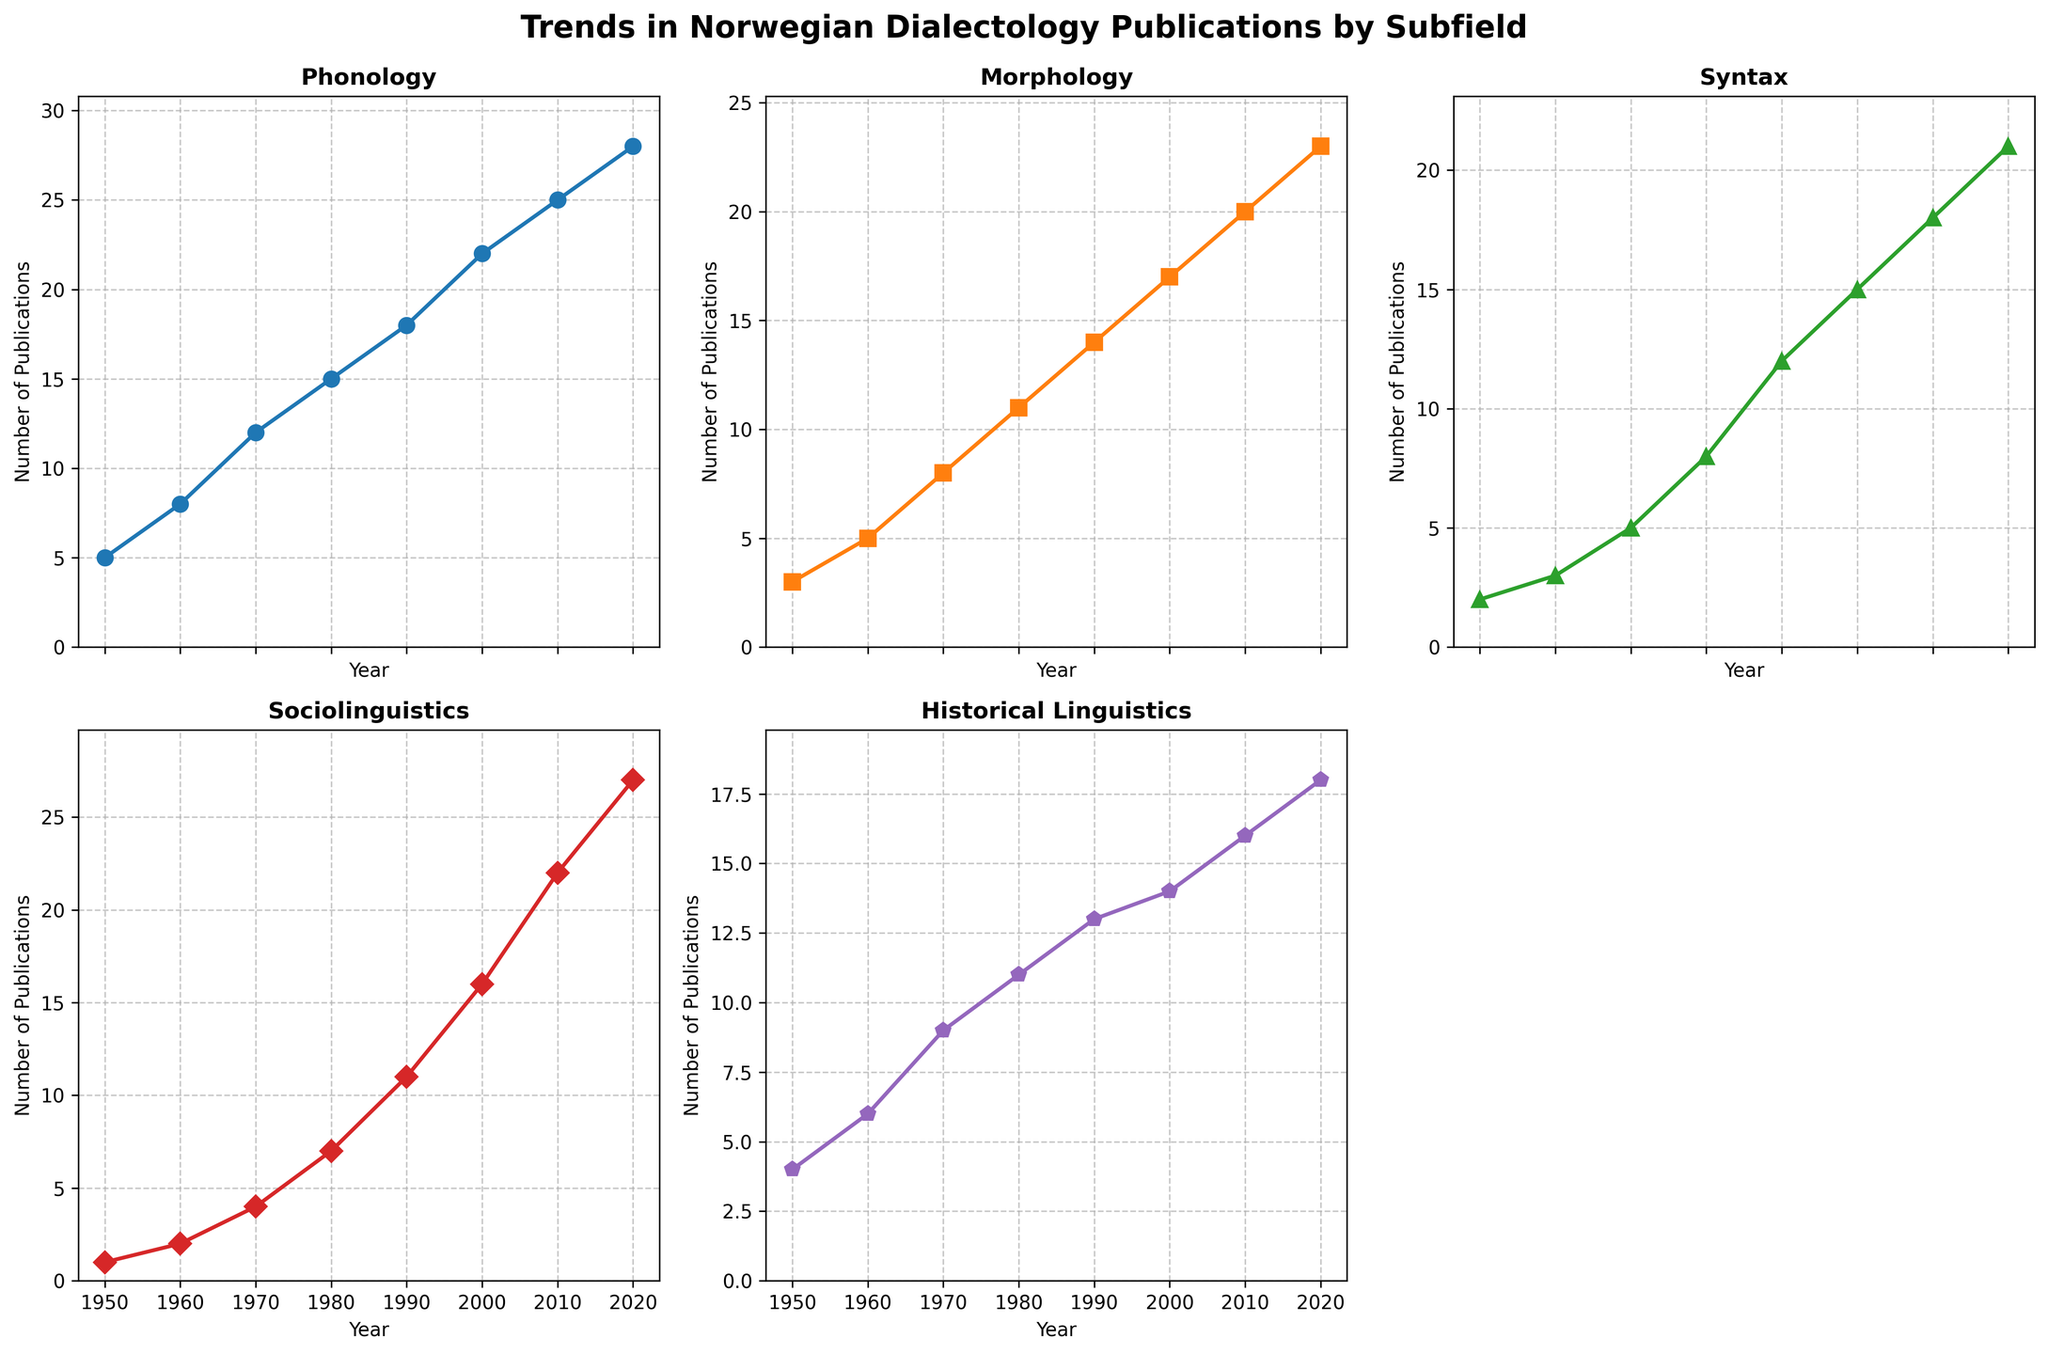Which subfield has the most publications in 2020? To find this, look at the y-values of each subplot line chart in 2020. The line with the highest y-value represents the subfield with the most publications.
Answer: Sociolinguistics Which subfield shows the fastest growth in publications from 1950 to 2020? Compare the slopes of the lines for each subfield from 1950 to 2020. The steepest slope indicates the fastest growth.
Answer: Sociolinguistics How many more publications were there in Syntax in 2020 compared to 1950? Locate the y-values for Syntax in 1950 (2) and in 2020 (21). Subtract the 1950 value from the 2020 value to get the difference.
Answer: 19 Which subfield had the least number of publications in 1990? Check the y-values of all subfields in 1990 across all subplots. The smallest value will identify the subfield with the least publications.
Answer: Phonology In which decade did Morphology surpass 20 publications? Observe the Morphology line chart and see in which decade the y-value first exceeds 20.
Answer: 2010s (around 2012) Which subfield maintained a steady rate of increase throughout the period? Examine the shapes of the lines to see which one has a consistent slope without sharp changes or fluctuations.
Answer: Phonology How do the publication trends for Historical Linguistics and Sociolinguistics differ over time? Look at the line charts for both fields. Historical Linguistics shows more gradual, slower growth, while Sociolinguistics shows steeper, faster growth, especially after 1980.
Answer: Historical Linguistics: slow growth, Sociolinguistics: rapid growth Did any subfield experience a decline in the total number of publications at any point? Check the line charts for any downward slopes indicating a drop in the number of publications over time.
Answer: No Which decade saw the largest increase in the number of publications across all subfields? Calculate the increment in publications for each subfield in each decade, and determine which decade had the highest combined increase. From 1980-1990, each field had significant increases.
Answer: 1980s What is the combined number of publications in 2020 for all subfields? Add up the y-values of all subfields for the year 2020: 28 (Phonology) + 23 (Morphology) + 21 (Syntax) + 27 (Sociolinguistics) + 18 (Historical Linguistics).
Answer: 117 